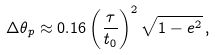Convert formula to latex. <formula><loc_0><loc_0><loc_500><loc_500>\Delta \theta _ { p } \approx 0 . 1 6 \left ( \frac { \tau } { t _ { 0 } } \right ) ^ { 2 } \sqrt { 1 - e ^ { 2 } } \, ,</formula> 